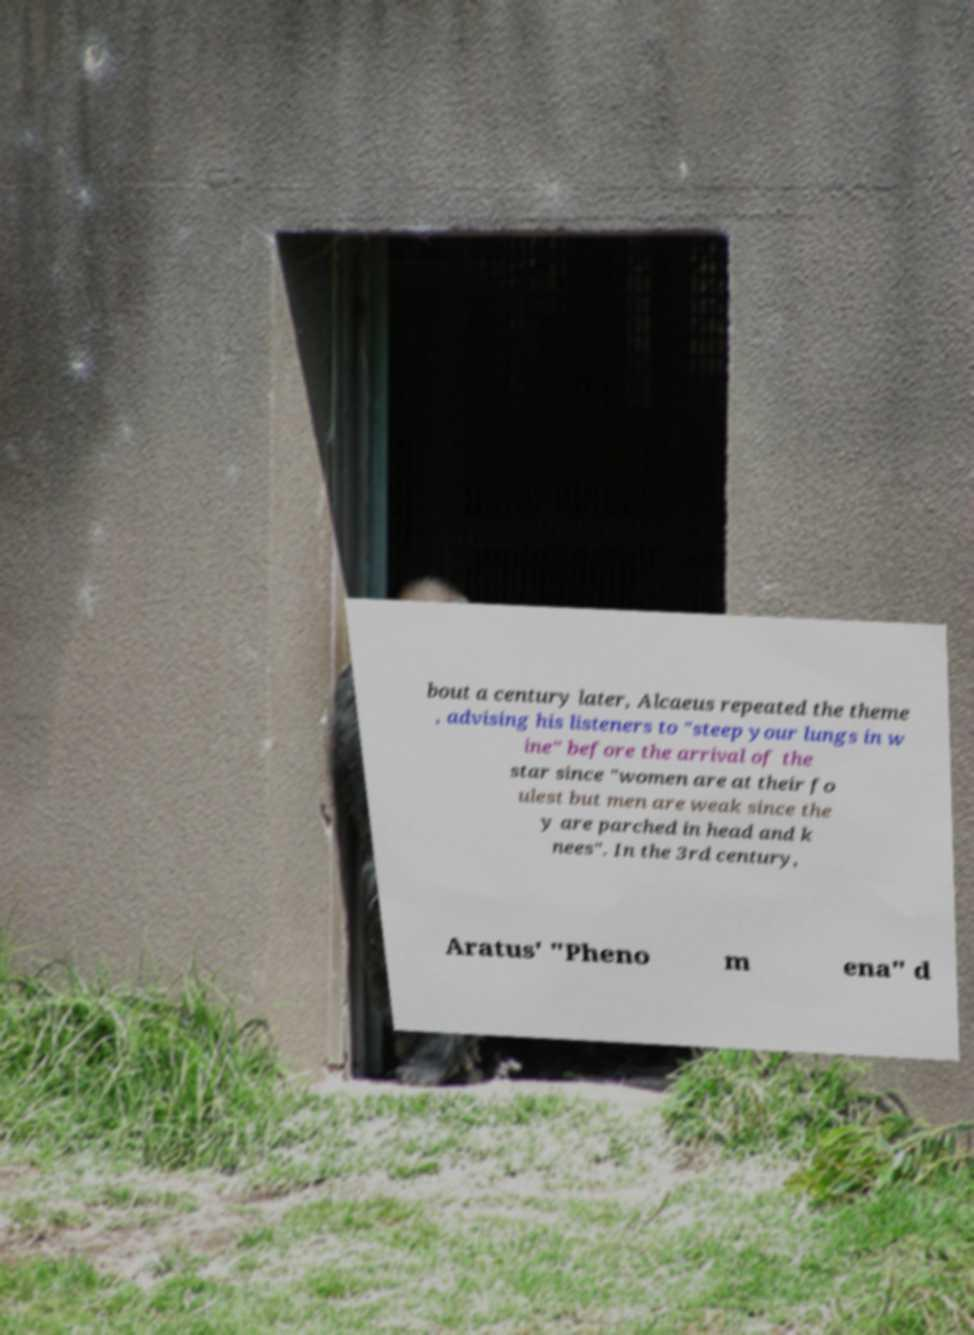For documentation purposes, I need the text within this image transcribed. Could you provide that? bout a century later, Alcaeus repeated the theme , advising his listeners to "steep your lungs in w ine" before the arrival of the star since "women are at their fo ulest but men are weak since the y are parched in head and k nees". In the 3rd century, Aratus' "Pheno m ena" d 